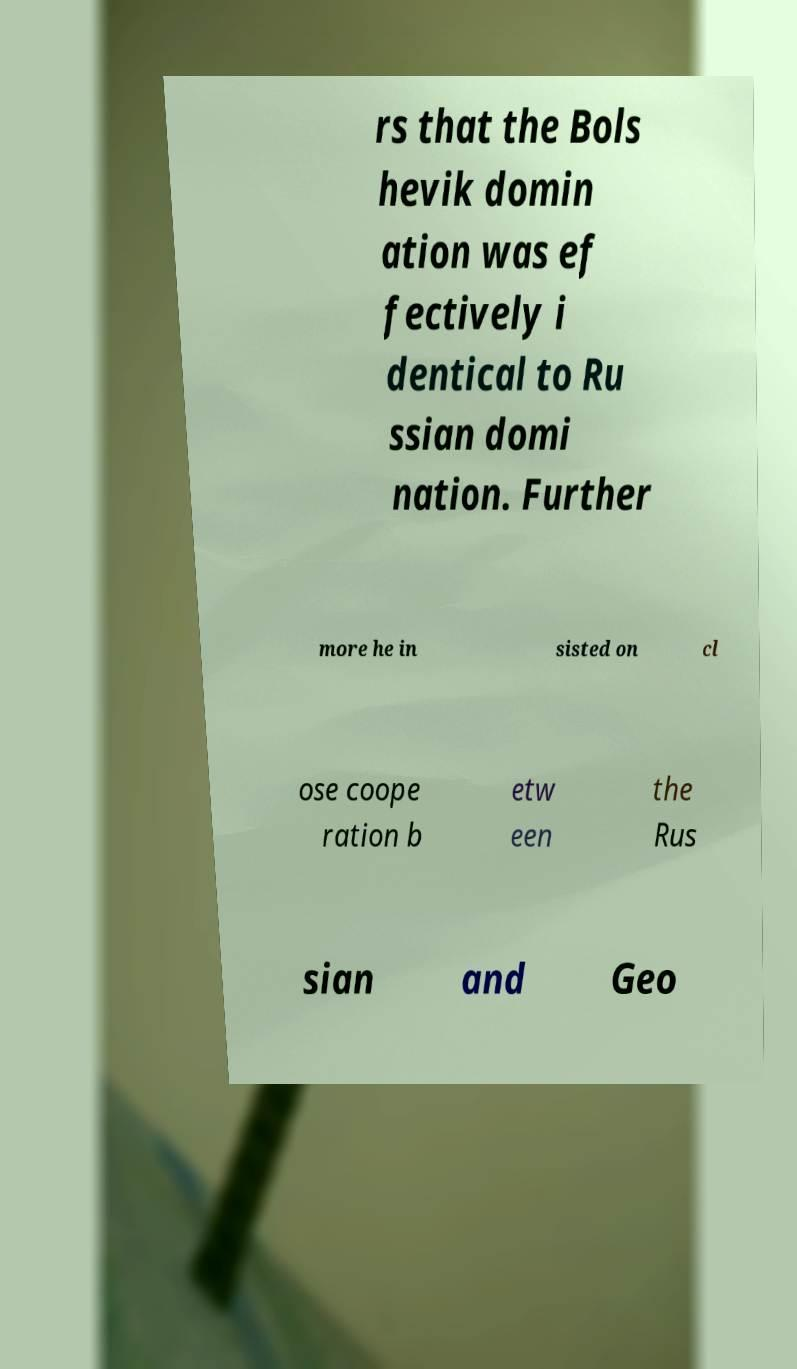Could you assist in decoding the text presented in this image and type it out clearly? rs that the Bols hevik domin ation was ef fectively i dentical to Ru ssian domi nation. Further more he in sisted on cl ose coope ration b etw een the Rus sian and Geo 